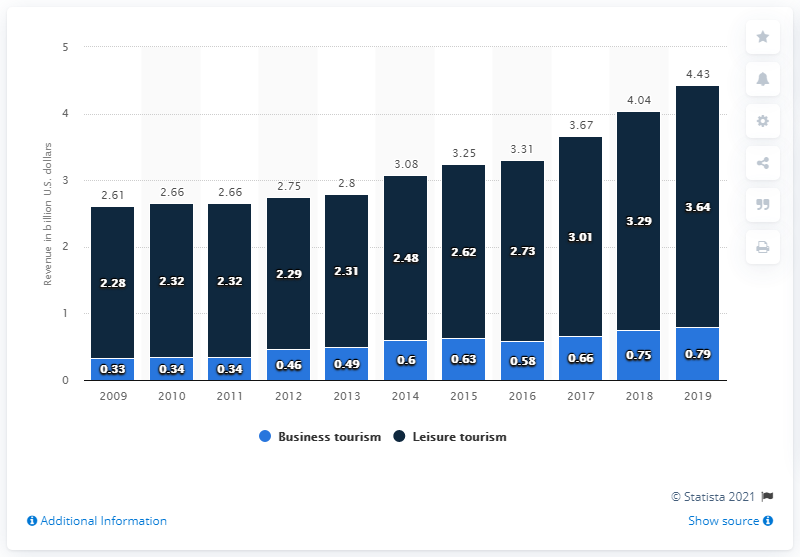Specify some key components in this picture. The difference between the blue bar from 2019 and 2018 is 0.04. The value of the combined bar in 2014 is 3.08. 